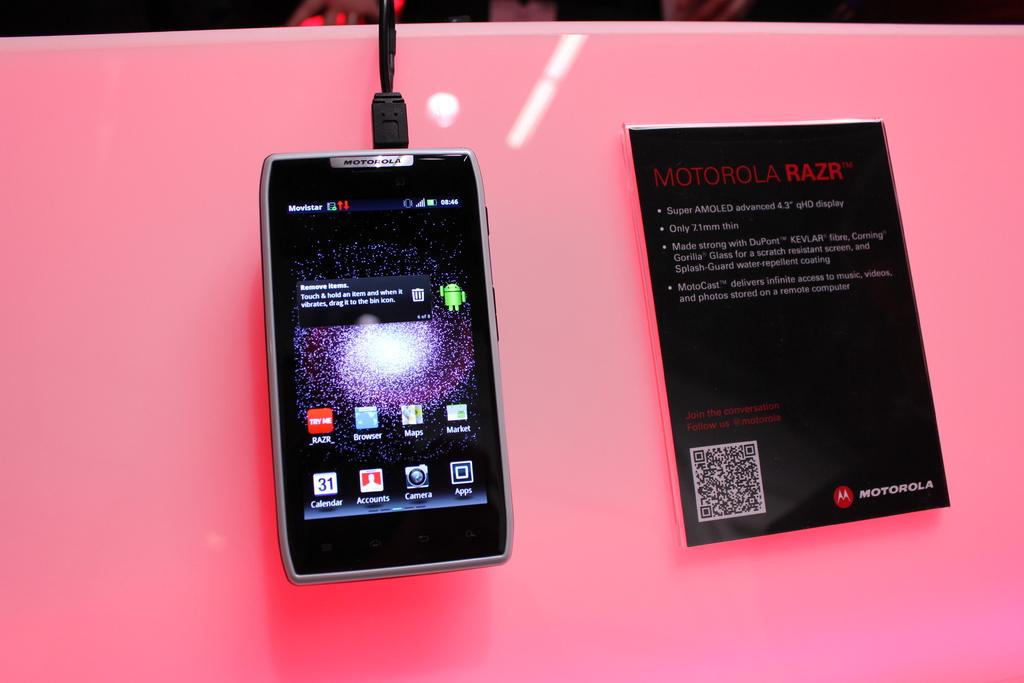What is the model of the phone?
Give a very brief answer. Motorola razr. What brand is the phone?
Your answer should be very brief. Motorola. 